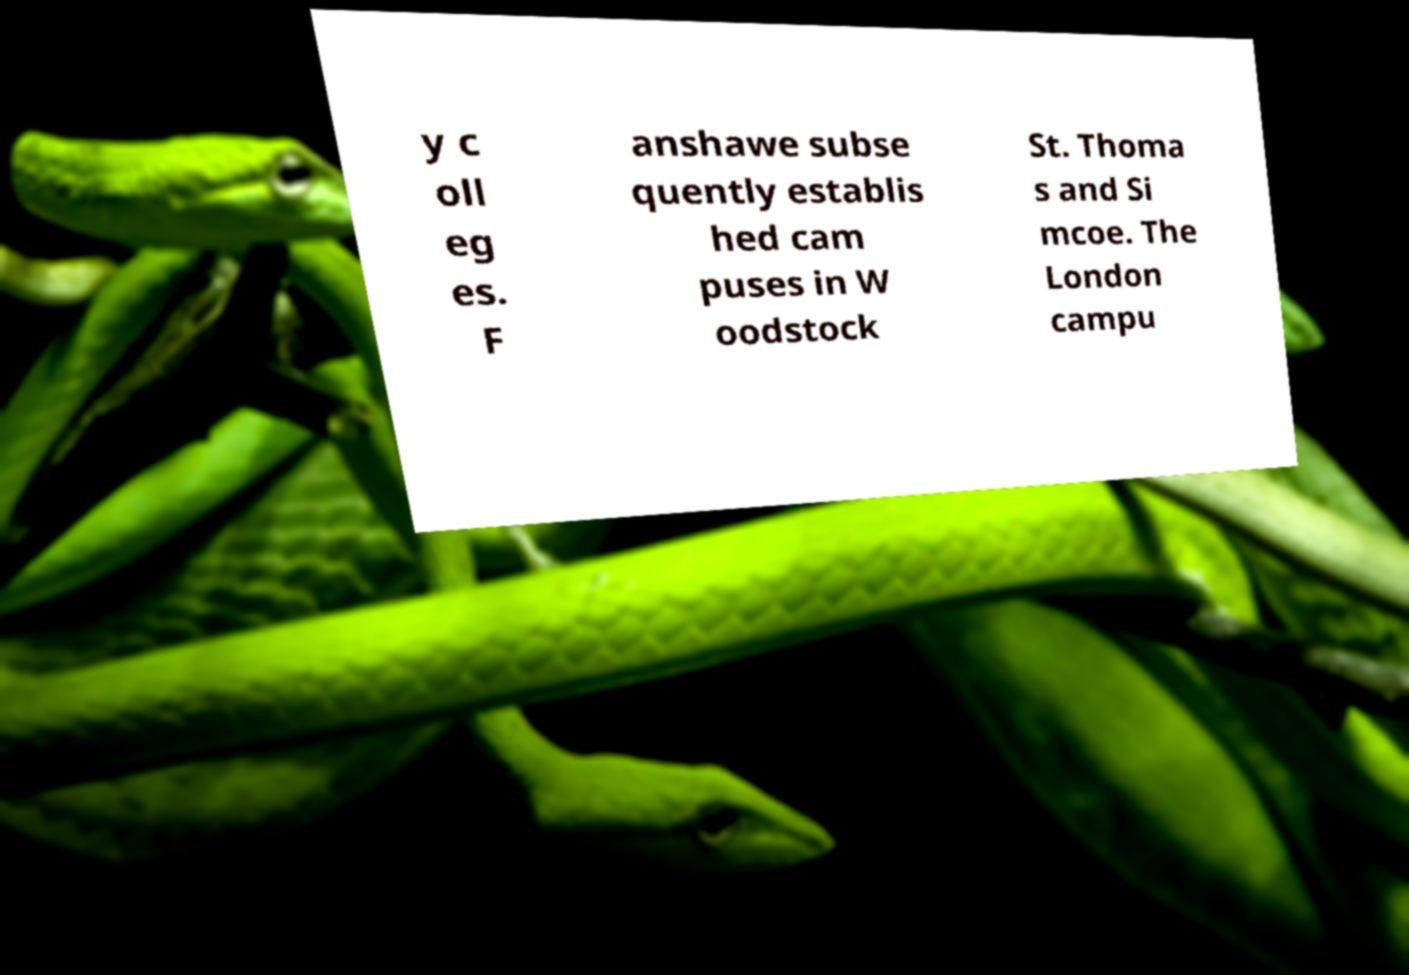Can you accurately transcribe the text from the provided image for me? y c oll eg es. F anshawe subse quently establis hed cam puses in W oodstock St. Thoma s and Si mcoe. The London campu 